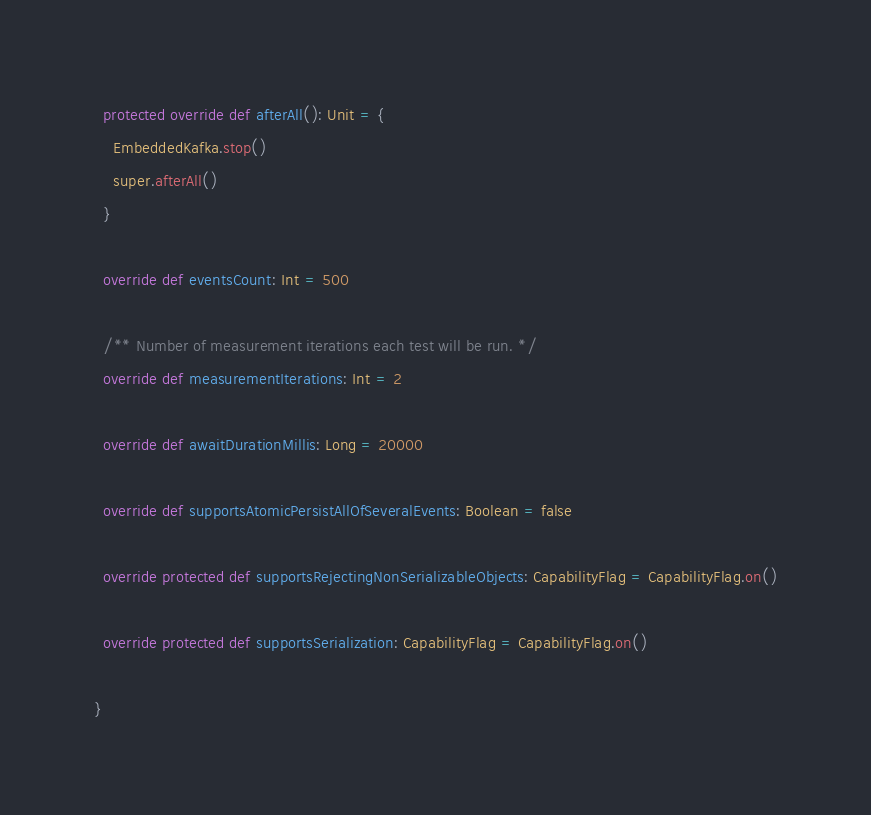Convert code to text. <code><loc_0><loc_0><loc_500><loc_500><_Scala_>
  protected override def afterAll(): Unit = {
    EmbeddedKafka.stop()
    super.afterAll()
  }

  override def eventsCount: Int = 500

  /** Number of measurement iterations each test will be run. */
  override def measurementIterations: Int = 2

  override def awaitDurationMillis: Long = 20000

  override def supportsAtomicPersistAllOfSeveralEvents: Boolean = false

  override protected def supportsRejectingNonSerializableObjects: CapabilityFlag = CapabilityFlag.on()

  override protected def supportsSerialization: CapabilityFlag = CapabilityFlag.on()

}
</code> 